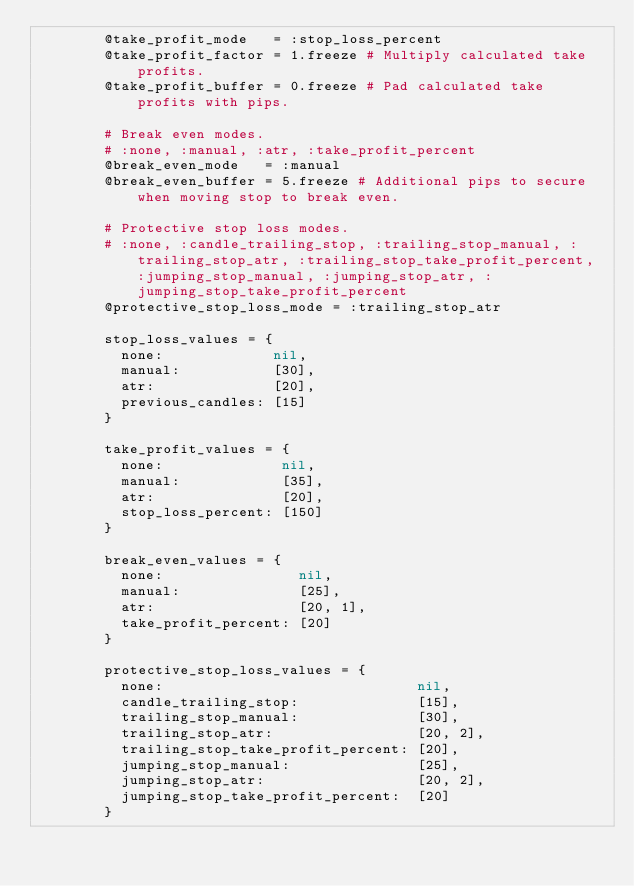<code> <loc_0><loc_0><loc_500><loc_500><_Ruby_>        @take_profit_mode   = :stop_loss_percent
        @take_profit_factor = 1.freeze # Multiply calculated take profits.
        @take_profit_buffer = 0.freeze # Pad calculated take profits with pips.

        # Break even modes.
        # :none, :manual, :atr, :take_profit_percent
        @break_even_mode   = :manual
        @break_even_buffer = 5.freeze # Additional pips to secure when moving stop to break even.

        # Protective stop loss modes.
        # :none, :candle_trailing_stop, :trailing_stop_manual, :trailing_stop_atr, :trailing_stop_take_profit_percent, :jumping_stop_manual, :jumping_stop_atr, :jumping_stop_take_profit_percent
        @protective_stop_loss_mode = :trailing_stop_atr

        stop_loss_values = {
          none:             nil,
          manual:           [30],
          atr:              [20],
          previous_candles: [15]
        }

        take_profit_values = {
          none:              nil,
          manual:            [35],
          atr:               [20],
          stop_loss_percent: [150]
        }

        break_even_values = {
          none:                nil,
          manual:              [25],
          atr:                 [20, 1],
          take_profit_percent: [20]
        }

        protective_stop_loss_values = {
          none:                              nil,
          candle_trailing_stop:              [15],
          trailing_stop_manual:              [30],
          trailing_stop_atr:                 [20, 2],
          trailing_stop_take_profit_percent: [20],
          jumping_stop_manual:               [25],
          jumping_stop_atr:                  [20, 2],
          jumping_stop_take_profit_percent:  [20]
        }
</code> 